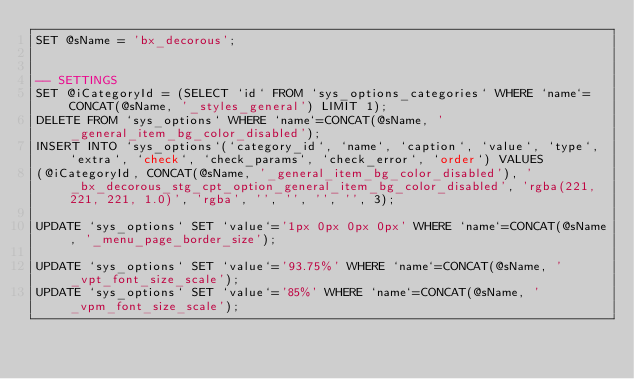Convert code to text. <code><loc_0><loc_0><loc_500><loc_500><_SQL_>SET @sName = 'bx_decorous';


-- SETTINGS
SET @iCategoryId = (SELECT `id` FROM `sys_options_categories` WHERE `name`=CONCAT(@sName, '_styles_general') LIMIT 1);
DELETE FROM `sys_options` WHERE `name`=CONCAT(@sName, '_general_item_bg_color_disabled');
INSERT INTO `sys_options`(`category_id`, `name`, `caption`, `value`, `type`, `extra`, `check`, `check_params`, `check_error`, `order`) VALUES
(@iCategoryId, CONCAT(@sName, '_general_item_bg_color_disabled'), '_bx_decorous_stg_cpt_option_general_item_bg_color_disabled', 'rgba(221, 221, 221, 1.0)', 'rgba', '', '', '', '', 3);

UPDATE `sys_options` SET `value`='1px 0px 0px 0px' WHERE `name`=CONCAT(@sName, '_menu_page_border_size');

UPDATE `sys_options` SET `value`='93.75%' WHERE `name`=CONCAT(@sName, '_vpt_font_size_scale');
UPDATE `sys_options` SET `value`='85%' WHERE `name`=CONCAT(@sName, '_vpm_font_size_scale');
</code> 